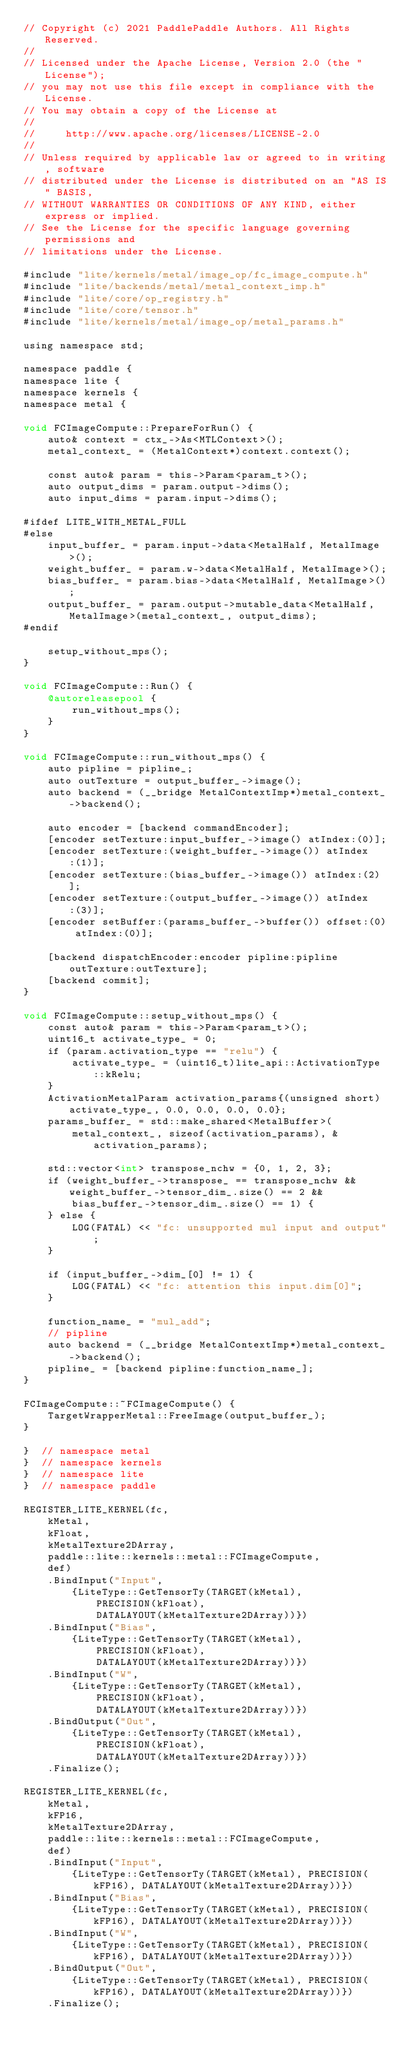Convert code to text. <code><loc_0><loc_0><loc_500><loc_500><_ObjectiveC_>// Copyright (c) 2021 PaddlePaddle Authors. All Rights Reserved.
//
// Licensed under the Apache License, Version 2.0 (the "License");
// you may not use this file except in compliance with the License.
// You may obtain a copy of the License at
//
//     http://www.apache.org/licenses/LICENSE-2.0
//
// Unless required by applicable law or agreed to in writing, software
// distributed under the License is distributed on an "AS IS" BASIS,
// WITHOUT WARRANTIES OR CONDITIONS OF ANY KIND, either express or implied.
// See the License for the specific language governing permissions and
// limitations under the License.

#include "lite/kernels/metal/image_op/fc_image_compute.h"
#include "lite/backends/metal/metal_context_imp.h"
#include "lite/core/op_registry.h"
#include "lite/core/tensor.h"
#include "lite/kernels/metal/image_op/metal_params.h"

using namespace std;

namespace paddle {
namespace lite {
namespace kernels {
namespace metal {

void FCImageCompute::PrepareForRun() {
    auto& context = ctx_->As<MTLContext>();
    metal_context_ = (MetalContext*)context.context();

    const auto& param = this->Param<param_t>();
    auto output_dims = param.output->dims();
    auto input_dims = param.input->dims();

#ifdef LITE_WITH_METAL_FULL
#else
    input_buffer_ = param.input->data<MetalHalf, MetalImage>();
    weight_buffer_ = param.w->data<MetalHalf, MetalImage>();
    bias_buffer_ = param.bias->data<MetalHalf, MetalImage>();
    output_buffer_ = param.output->mutable_data<MetalHalf, MetalImage>(metal_context_, output_dims);
#endif

    setup_without_mps();
}

void FCImageCompute::Run() {
    @autoreleasepool {
        run_without_mps();
    }
}

void FCImageCompute::run_without_mps() {
    auto pipline = pipline_;
    auto outTexture = output_buffer_->image();
    auto backend = (__bridge MetalContextImp*)metal_context_->backend();

    auto encoder = [backend commandEncoder];
    [encoder setTexture:input_buffer_->image() atIndex:(0)];
    [encoder setTexture:(weight_buffer_->image()) atIndex:(1)];
    [encoder setTexture:(bias_buffer_->image()) atIndex:(2)];
    [encoder setTexture:(output_buffer_->image()) atIndex:(3)];
    [encoder setBuffer:(params_buffer_->buffer()) offset:(0) atIndex:(0)];

    [backend dispatchEncoder:encoder pipline:pipline outTexture:outTexture];
    [backend commit];
}

void FCImageCompute::setup_without_mps() {
    const auto& param = this->Param<param_t>();
    uint16_t activate_type_ = 0;
    if (param.activation_type == "relu") {
        activate_type_ = (uint16_t)lite_api::ActivationType::kRelu;
    }
    ActivationMetalParam activation_params{(unsigned short)activate_type_, 0.0, 0.0, 0.0, 0.0};
    params_buffer_ = std::make_shared<MetalBuffer>(
        metal_context_, sizeof(activation_params), &activation_params);

    std::vector<int> transpose_nchw = {0, 1, 2, 3};
    if (weight_buffer_->transpose_ == transpose_nchw && weight_buffer_->tensor_dim_.size() == 2 &&
        bias_buffer_->tensor_dim_.size() == 1) {
    } else {
        LOG(FATAL) << "fc: unsupported mul input and output";
    }

    if (input_buffer_->dim_[0] != 1) {
        LOG(FATAL) << "fc: attention this input.dim[0]";
    }

    function_name_ = "mul_add";
    // pipline
    auto backend = (__bridge MetalContextImp*)metal_context_->backend();
    pipline_ = [backend pipline:function_name_];
}

FCImageCompute::~FCImageCompute() {
    TargetWrapperMetal::FreeImage(output_buffer_);
}

}  // namespace metal
}  // namespace kernels
}  // namespace lite
}  // namespace paddle

REGISTER_LITE_KERNEL(fc,
    kMetal,
    kFloat,
    kMetalTexture2DArray,
    paddle::lite::kernels::metal::FCImageCompute,
    def)
    .BindInput("Input",
        {LiteType::GetTensorTy(TARGET(kMetal),
            PRECISION(kFloat),
            DATALAYOUT(kMetalTexture2DArray))})
    .BindInput("Bias",
        {LiteType::GetTensorTy(TARGET(kMetal),
            PRECISION(kFloat),
            DATALAYOUT(kMetalTexture2DArray))})
    .BindInput("W",
        {LiteType::GetTensorTy(TARGET(kMetal),
            PRECISION(kFloat),
            DATALAYOUT(kMetalTexture2DArray))})
    .BindOutput("Out",
        {LiteType::GetTensorTy(TARGET(kMetal),
            PRECISION(kFloat),
            DATALAYOUT(kMetalTexture2DArray))})
    .Finalize();

REGISTER_LITE_KERNEL(fc,
    kMetal,
    kFP16,
    kMetalTexture2DArray,
    paddle::lite::kernels::metal::FCImageCompute,
    def)
    .BindInput("Input",
        {LiteType::GetTensorTy(TARGET(kMetal), PRECISION(kFP16), DATALAYOUT(kMetalTexture2DArray))})
    .BindInput("Bias",
        {LiteType::GetTensorTy(TARGET(kMetal), PRECISION(kFP16), DATALAYOUT(kMetalTexture2DArray))})
    .BindInput("W",
        {LiteType::GetTensorTy(TARGET(kMetal), PRECISION(kFP16), DATALAYOUT(kMetalTexture2DArray))})
    .BindOutput("Out",
        {LiteType::GetTensorTy(TARGET(kMetal), PRECISION(kFP16), DATALAYOUT(kMetalTexture2DArray))})
    .Finalize();
</code> 